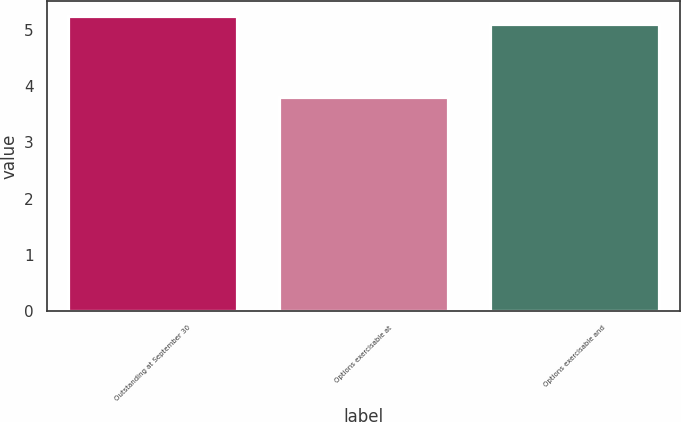<chart> <loc_0><loc_0><loc_500><loc_500><bar_chart><fcel>Outstanding at September 30<fcel>Options exercisable at<fcel>Options exercisable and<nl><fcel>5.24<fcel>3.8<fcel>5.1<nl></chart> 